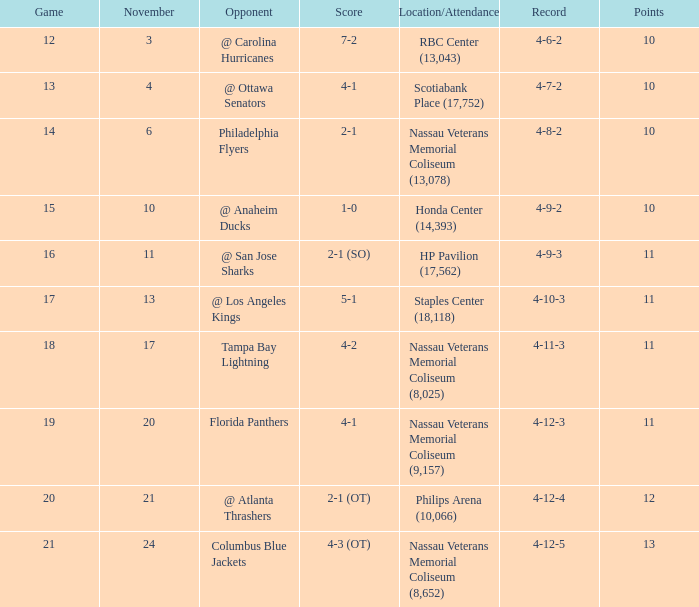What is the highest amount of points? 13.0. 